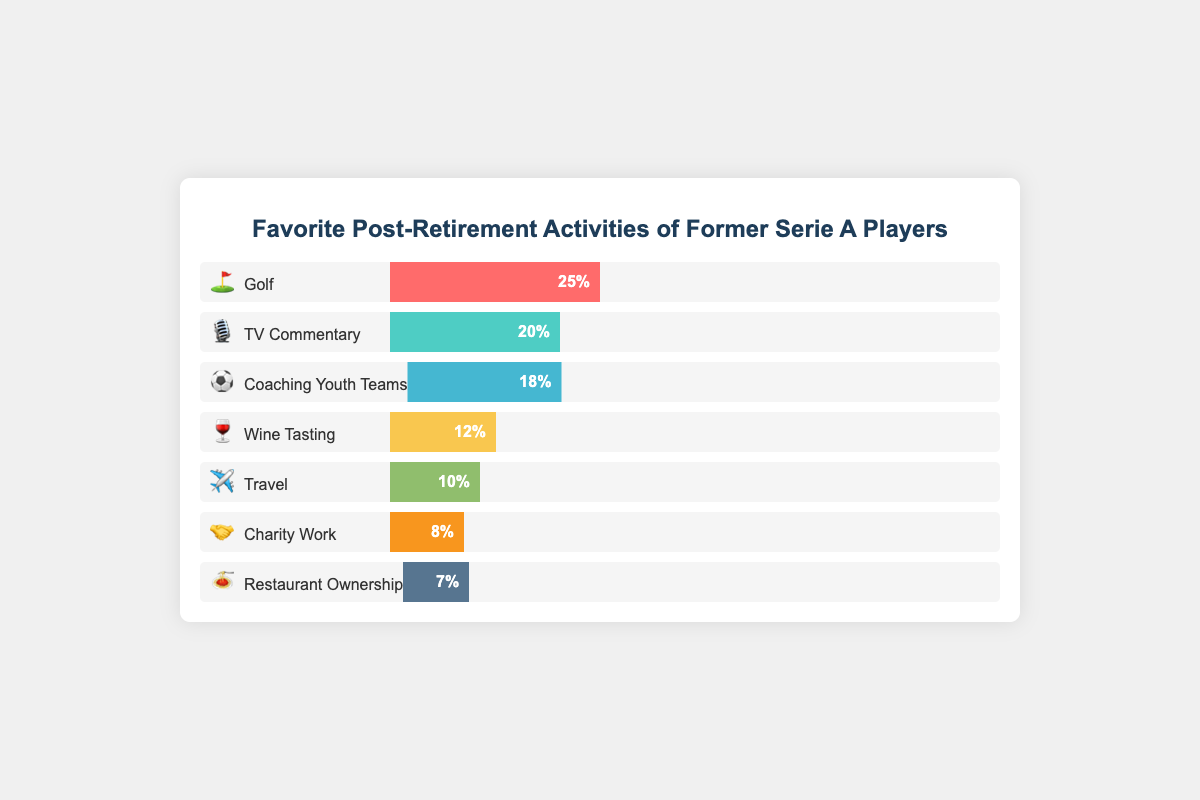What's the most popular post-retirement activity among former Serie A players? The bar with the largest percentage represents the most popular activity. "Golf" (⛳) is shown with a 25% share, making it the most popular.
Answer: Golf (⛳) Which activity is the least popular? The activity with the smallest percentage is the least popular. "Restaurant Ownership" (🍝) has only 7%, making it the least popular.
Answer: Restaurant Ownership (🍝) What percentage of former Serie A players engage in TV commentary? The section for "TV Commentary" (🎙️) shows 20%, meaning 20% of players engage in this activity.
Answer: 20% How much more popular is Golf compared to Coaching Youth Teams? Golf has 25% while Coaching Youth Teams has 18%. The difference is calculated as 25% - 18% = 7%.
Answer: 7% Combine the percentages of the three least popular activities. What's their total? The three least popular activities are Wine Tasting (12%), Charity Work (8%), and Restaurant Ownership (7%). Adding them gives 12% + 8% + 7% = 27%.
Answer: 27% Which activities are more popular than Travel? Activities with a higher percentage than Travel (10%) are Golf (25%), TV Commentary (20%), and Coaching Youth Teams (18%).
Answer: Golf, TV Commentary, Coaching Youth Teams Out of all the activities, which one involves the highest percentage of travel-related interests? The Travel (✈️) category is related explicitly to travel and stands at 10%.
Answer: Travel (✈️) How many activities have a representation of at least 10% among former Serie A players? Counting the activities with at least 10%: Golf (25%), TV Commentary (20%), Coaching Youth Teams (18%), Wine Tasting (12%), and Travel (10%). There are 5 such activities.
Answer: 5 By how much does the percentage for Charity Work differ from TV Commentary? TV Commentary is at 20%, and Charity Work is at 8%. The difference is 20% - 8% = 12%.
Answer: 12% 